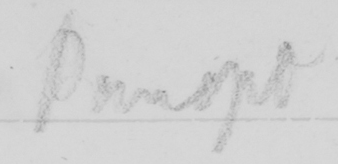What is written in this line of handwriting? Panopt 